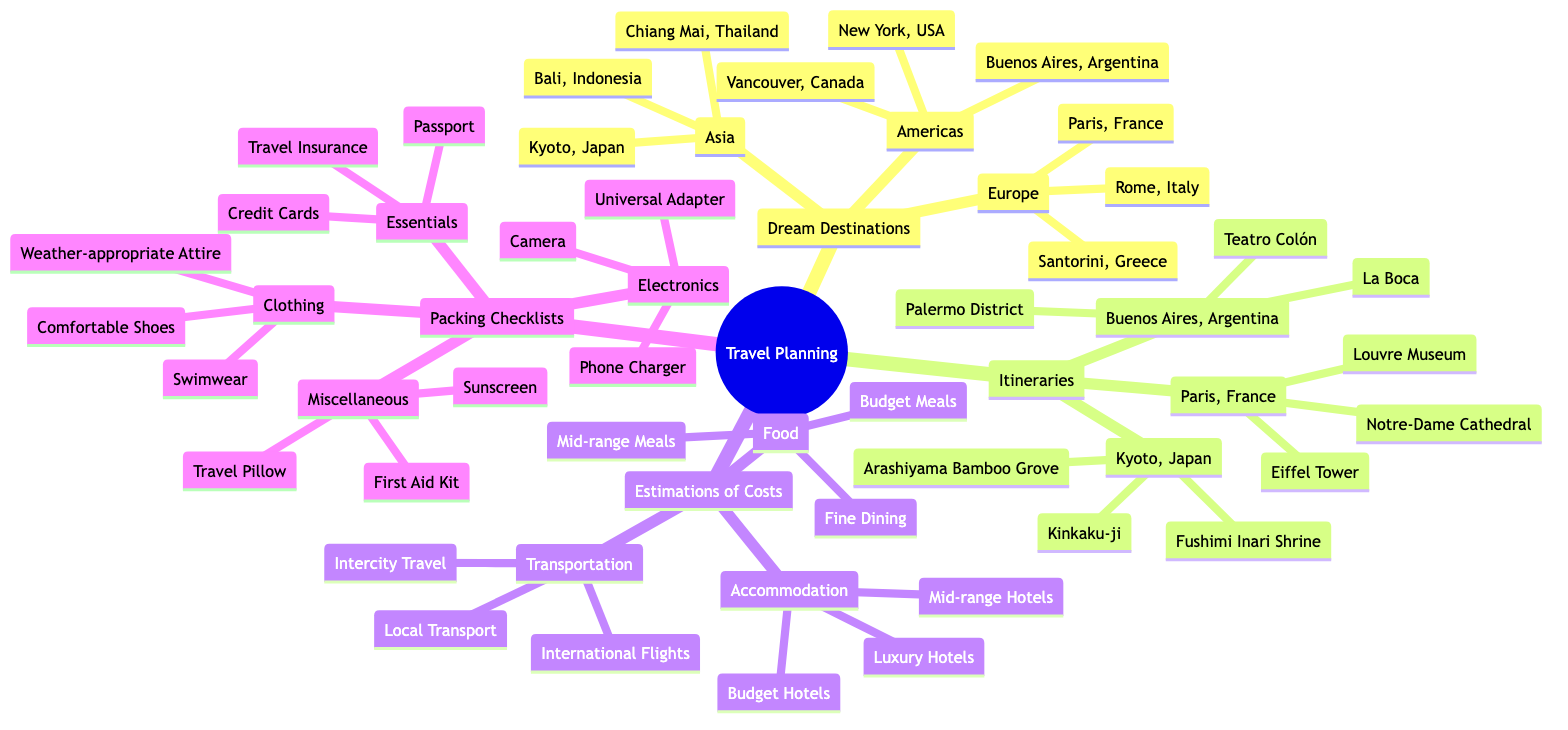What are three dream destinations in Europe? The diagram lists Europe under Dream Destinations, with associated cities being Paris, France; Rome, Italy; and Santorini, Greece.
Answer: Paris, France; Rome, Italy; Santorini, Greece What is the first attraction in Paris, France? The Itineraries section for Paris, France lists three attractions, and the first one mentioned is the Eiffel Tower.
Answer: Eiffel Tower How many countries are represented in Asia's dream destinations? The Asia section under Dream Destinations includes three countries: Japan, Indonesia, and Thailand. Thus, the total number is three.
Answer: 3 What type of meals cost between 15 and 30 USD? The Estimations of Costs section for Food lists Mid-range Meals with a cost range of 15-30 USD, fulfilling the query.
Answer: Mid-range Meals What is the accommodation cost range for budget hotels? Under the Estimations of Costs section, the accommodation type Budget Hotels is specified to cost between 50-100 USD per night.
Answer: 50-100 USD per night Which packing checklist category includes a sunscreen? Sunscreen is listed under the Miscellaneous category in the Packing Checklists section, identifying the specific category requested.
Answer: Miscellaneous Which attraction is mentioned last for Kyoto, Japan? The Itineraries section for Kyoto, Japan lists three attractions in order, with Arashiyama Bamboo Grove being the last one mentioned.
Answer: Arashiyama Bamboo Grove What is the estimated cost for local transport? In the Estimations of Costs section, Local Transport is mentioned with a cost range of 2-10 USD per ride, providing a direct answer to the question.
Answer: 2-10 USD per ride What essential item is found in the packing checklist? The Packing Checklists section specifies "Passport" as one of the essential items, answering the question regarding the essential category.
Answer: Passport 